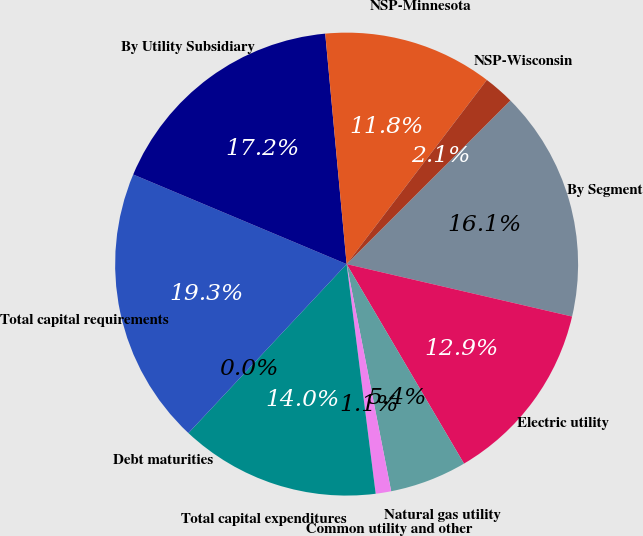Convert chart. <chart><loc_0><loc_0><loc_500><loc_500><pie_chart><fcel>By Segment<fcel>Electric utility<fcel>Natural gas utility<fcel>Common utility and other<fcel>Total capital expenditures<fcel>Debt maturities<fcel>Total capital requirements<fcel>By Utility Subsidiary<fcel>NSP-Minnesota<fcel>NSP-Wisconsin<nl><fcel>16.13%<fcel>12.9%<fcel>5.38%<fcel>1.08%<fcel>13.98%<fcel>0.0%<fcel>19.35%<fcel>17.2%<fcel>11.83%<fcel>2.15%<nl></chart> 